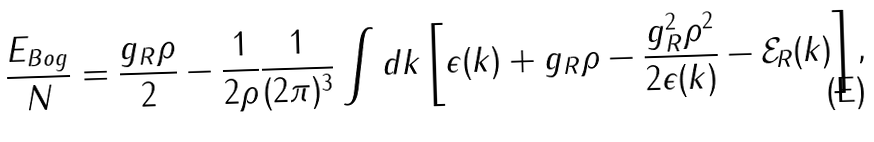<formula> <loc_0><loc_0><loc_500><loc_500>\frac { E _ { B o g } } { N } = \frac { g _ { R } \rho } { 2 } - \frac { 1 } { 2 \rho } \frac { 1 } { ( 2 \pi ) ^ { 3 } } \int d k \left [ \epsilon ( k ) + g _ { R } \rho - \frac { g _ { R } ^ { 2 } \rho ^ { 2 } } { 2 \epsilon ( k ) } - \mathcal { E } _ { R } ( k ) \right ] ,</formula> 